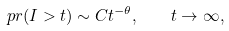<formula> <loc_0><loc_0><loc_500><loc_500>\ p r ( I > t ) \sim C t ^ { - \theta } , \quad t \to \infty ,</formula> 